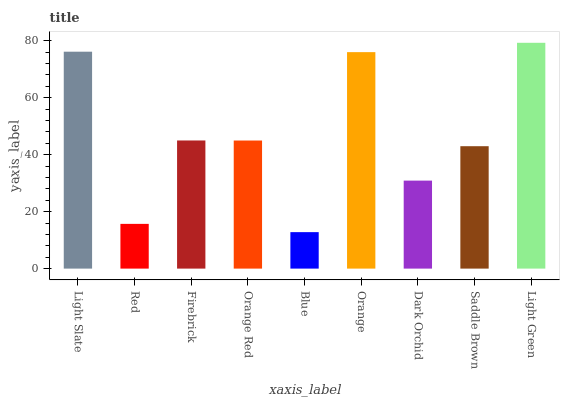Is Blue the minimum?
Answer yes or no. Yes. Is Light Green the maximum?
Answer yes or no. Yes. Is Red the minimum?
Answer yes or no. No. Is Red the maximum?
Answer yes or no. No. Is Light Slate greater than Red?
Answer yes or no. Yes. Is Red less than Light Slate?
Answer yes or no. Yes. Is Red greater than Light Slate?
Answer yes or no. No. Is Light Slate less than Red?
Answer yes or no. No. Is Orange Red the high median?
Answer yes or no. Yes. Is Orange Red the low median?
Answer yes or no. Yes. Is Light Slate the high median?
Answer yes or no. No. Is Dark Orchid the low median?
Answer yes or no. No. 